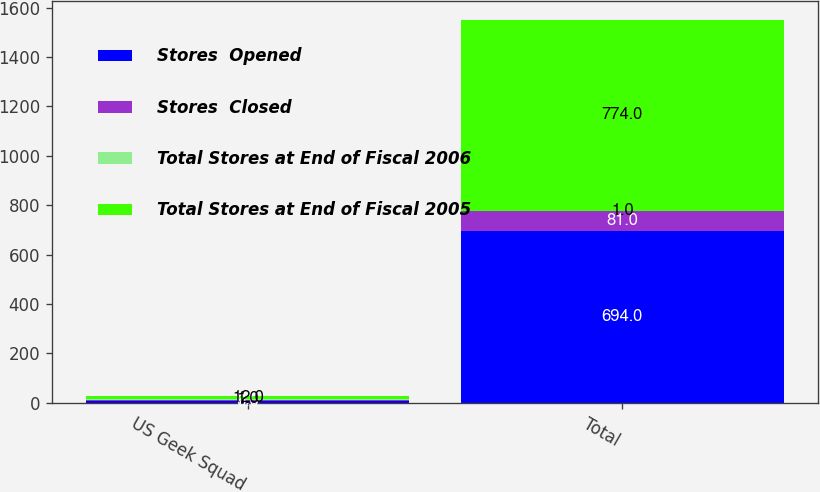Convert chart. <chart><loc_0><loc_0><loc_500><loc_500><stacked_bar_chart><ecel><fcel>US Geek Squad<fcel>Total<nl><fcel>Stores  Opened<fcel>6<fcel>694<nl><fcel>Stores  Closed<fcel>7<fcel>81<nl><fcel>Total Stores at End of Fiscal 2006<fcel>1<fcel>1<nl><fcel>Total Stores at End of Fiscal 2005<fcel>12<fcel>774<nl></chart> 